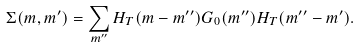Convert formula to latex. <formula><loc_0><loc_0><loc_500><loc_500>\Sigma ( m , m ^ { \prime } ) = \sum _ { m ^ { \prime \prime } } H _ { T } ( m - m ^ { \prime \prime } ) G _ { 0 } ( m ^ { \prime \prime } ) H _ { T } ( m ^ { \prime \prime } - m ^ { \prime } ) .</formula> 